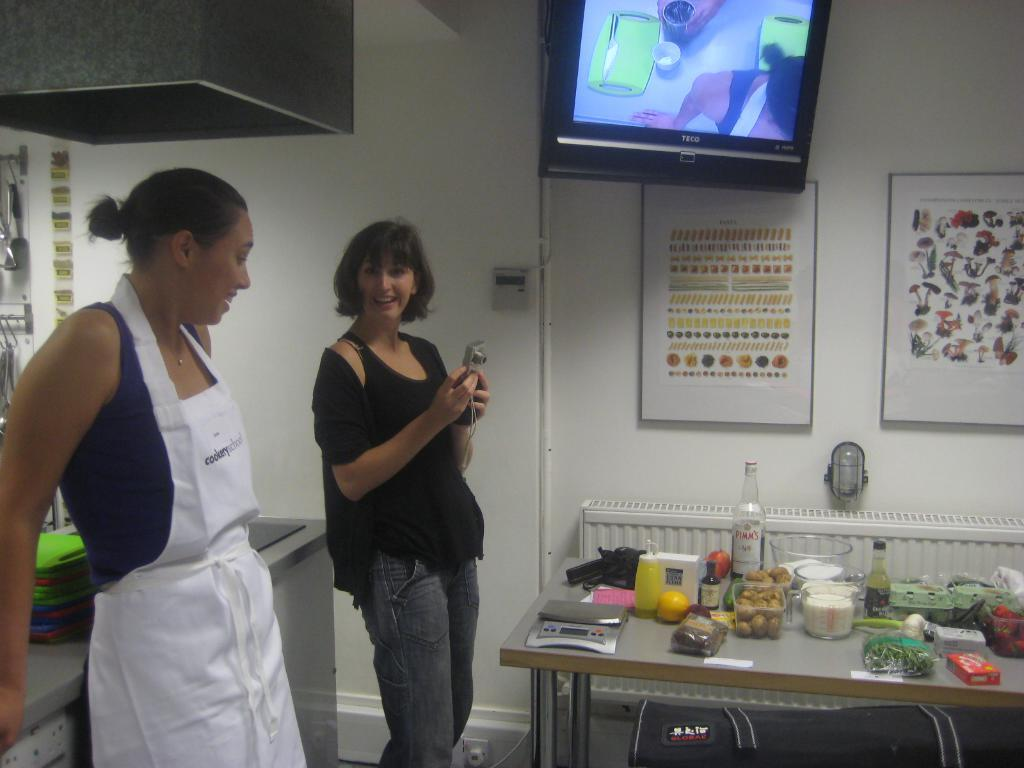<image>
Describe the image concisely. Two ladies standing on the side of a table with many food items on it and one has an apron on that says cookery. 